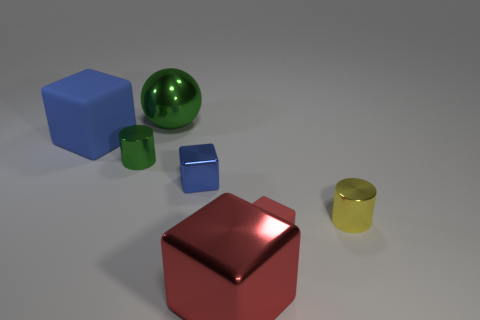If we categorize the objects by shape, how many groups can we form? Objects can be grouped into three shape categories: cubes, cylinders, and a sphere. There are two cubes, two cylinders, and one sphere. 